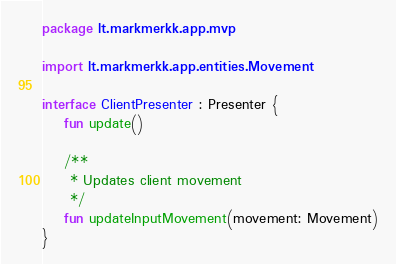<code> <loc_0><loc_0><loc_500><loc_500><_Kotlin_>package lt.markmerkk.app.mvp

import lt.markmerkk.app.entities.Movement

interface ClientPresenter : Presenter {
    fun update()

    /**
     * Updates client movement
     */
    fun updateInputMovement(movement: Movement)
}</code> 